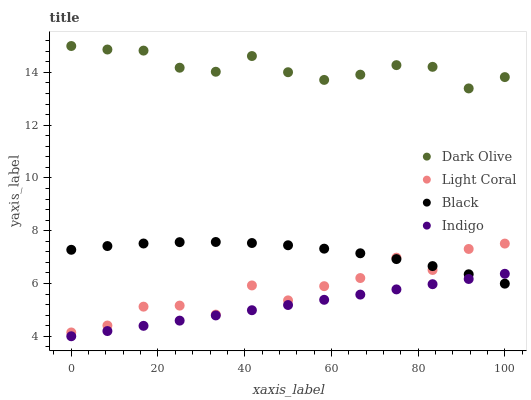Does Indigo have the minimum area under the curve?
Answer yes or no. Yes. Does Dark Olive have the maximum area under the curve?
Answer yes or no. Yes. Does Dark Olive have the minimum area under the curve?
Answer yes or no. No. Does Indigo have the maximum area under the curve?
Answer yes or no. No. Is Indigo the smoothest?
Answer yes or no. Yes. Is Light Coral the roughest?
Answer yes or no. Yes. Is Dark Olive the smoothest?
Answer yes or no. No. Is Dark Olive the roughest?
Answer yes or no. No. Does Indigo have the lowest value?
Answer yes or no. Yes. Does Dark Olive have the lowest value?
Answer yes or no. No. Does Dark Olive have the highest value?
Answer yes or no. Yes. Does Indigo have the highest value?
Answer yes or no. No. Is Indigo less than Light Coral?
Answer yes or no. Yes. Is Dark Olive greater than Indigo?
Answer yes or no. Yes. Does Indigo intersect Black?
Answer yes or no. Yes. Is Indigo less than Black?
Answer yes or no. No. Is Indigo greater than Black?
Answer yes or no. No. Does Indigo intersect Light Coral?
Answer yes or no. No. 